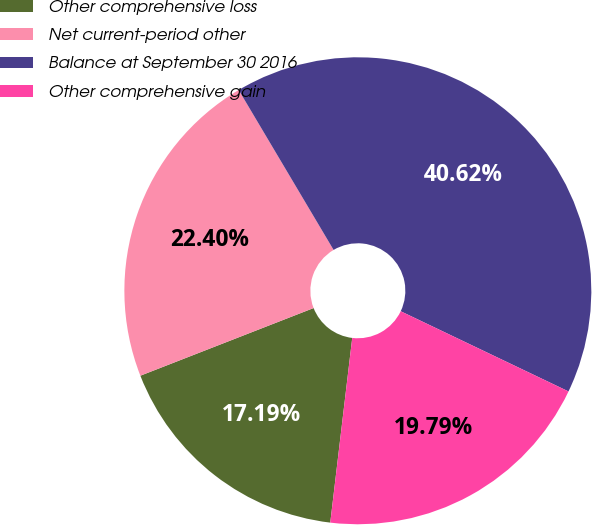<chart> <loc_0><loc_0><loc_500><loc_500><pie_chart><fcel>Other comprehensive loss<fcel>Net current-period other<fcel>Balance at September 30 2016<fcel>Other comprehensive gain<nl><fcel>17.19%<fcel>22.4%<fcel>40.62%<fcel>19.79%<nl></chart> 